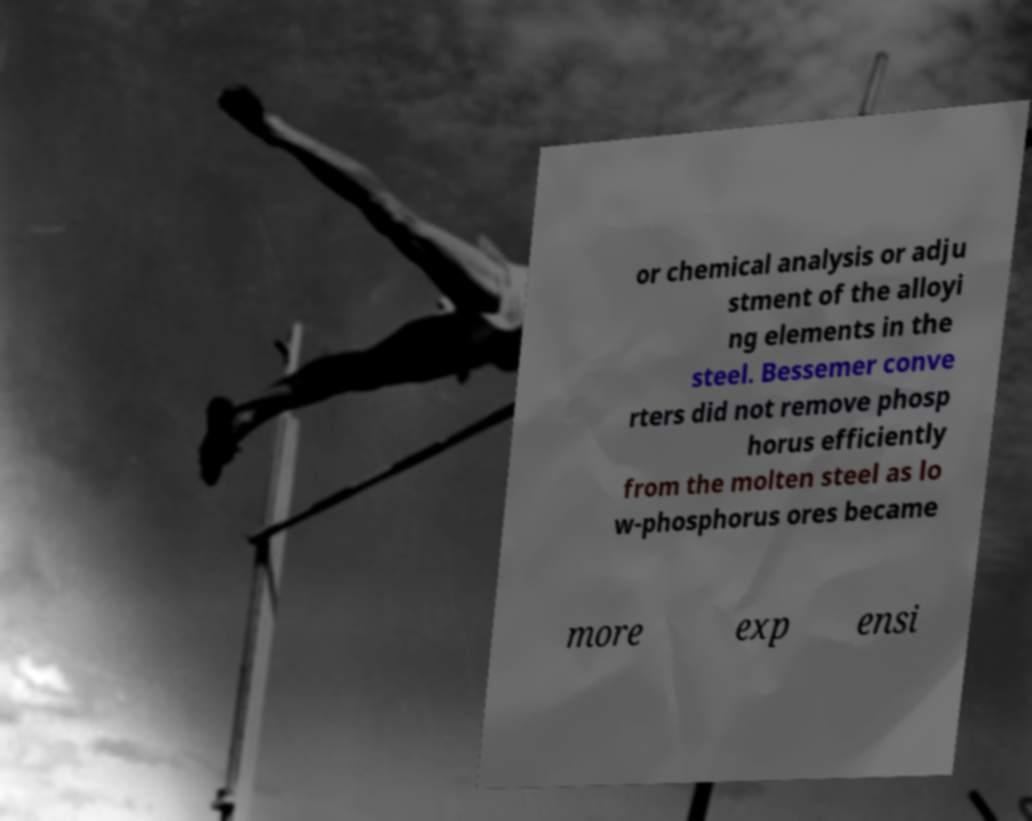What messages or text are displayed in this image? I need them in a readable, typed format. or chemical analysis or adju stment of the alloyi ng elements in the steel. Bessemer conve rters did not remove phosp horus efficiently from the molten steel as lo w-phosphorus ores became more exp ensi 